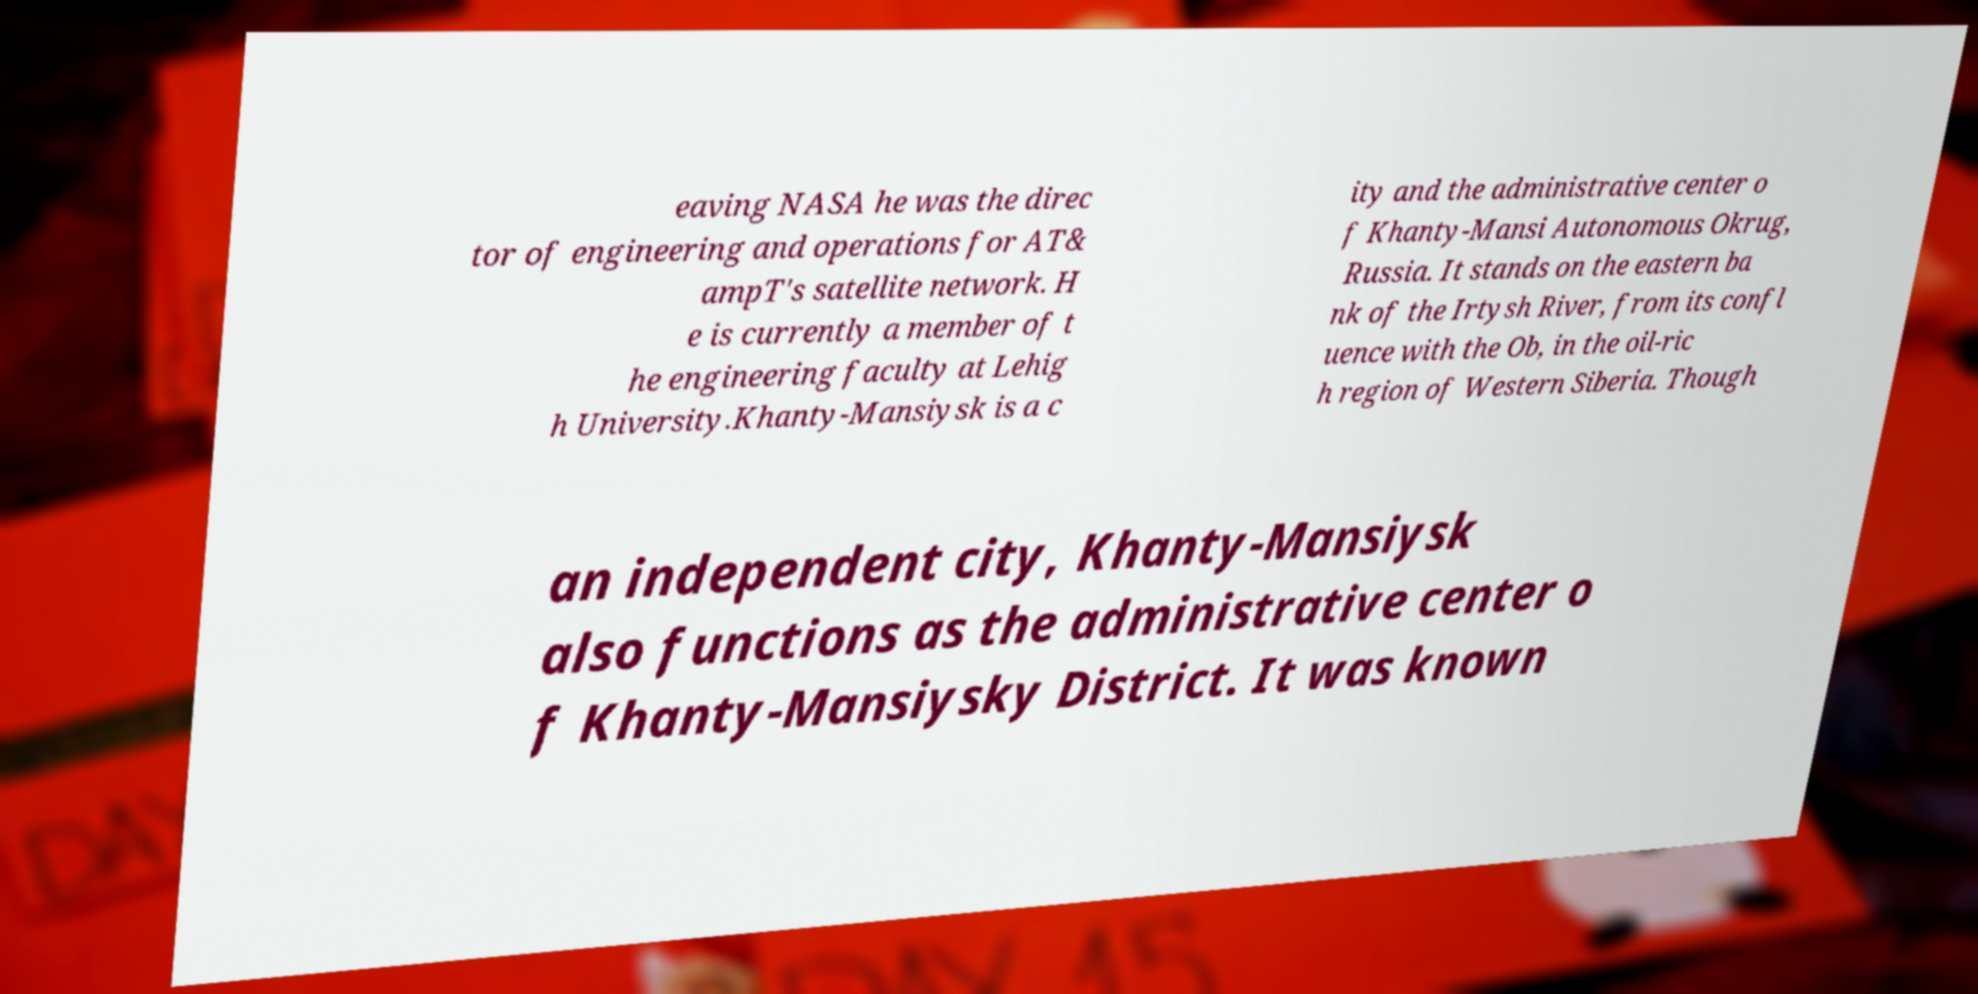Please read and relay the text visible in this image. What does it say? eaving NASA he was the direc tor of engineering and operations for AT& ampT's satellite network. H e is currently a member of t he engineering faculty at Lehig h University.Khanty-Mansiysk is a c ity and the administrative center o f Khanty-Mansi Autonomous Okrug, Russia. It stands on the eastern ba nk of the Irtysh River, from its confl uence with the Ob, in the oil-ric h region of Western Siberia. Though an independent city, Khanty-Mansiysk also functions as the administrative center o f Khanty-Mansiysky District. It was known 